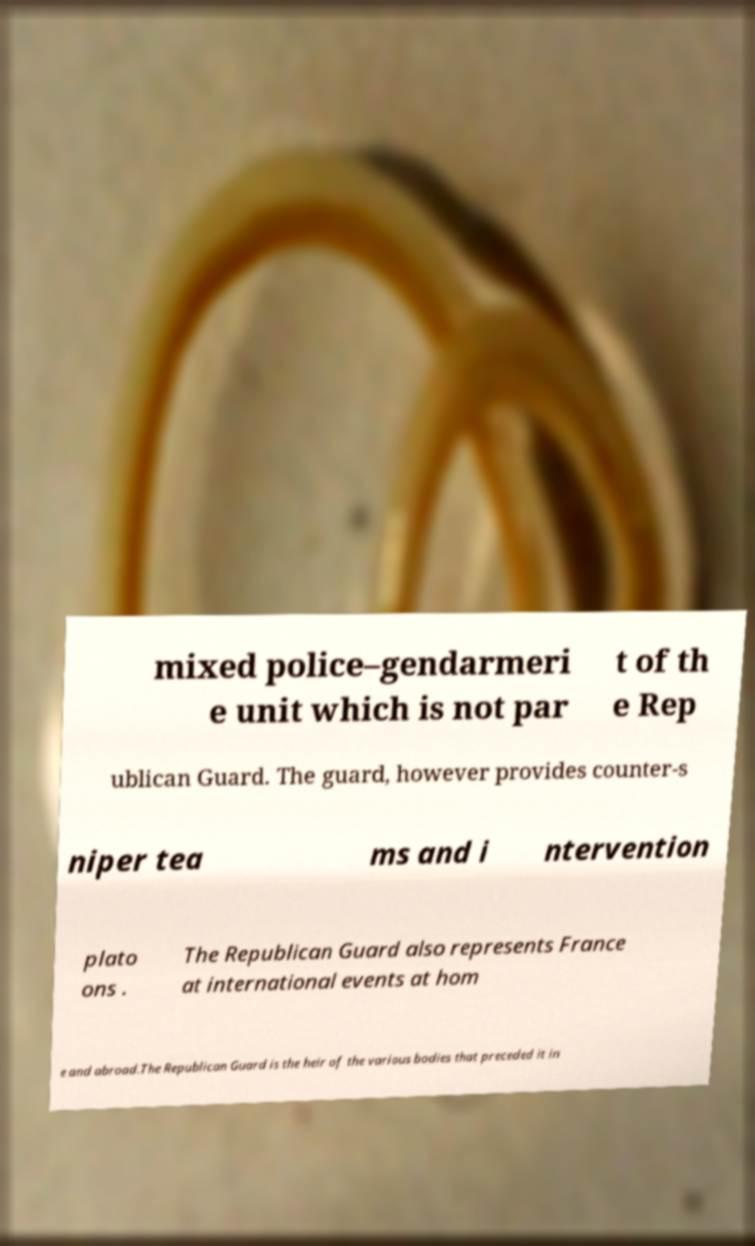Can you accurately transcribe the text from the provided image for me? mixed police–gendarmeri e unit which is not par t of th e Rep ublican Guard. The guard, however provides counter-s niper tea ms and i ntervention plato ons . The Republican Guard also represents France at international events at hom e and abroad.The Republican Guard is the heir of the various bodies that preceded it in 